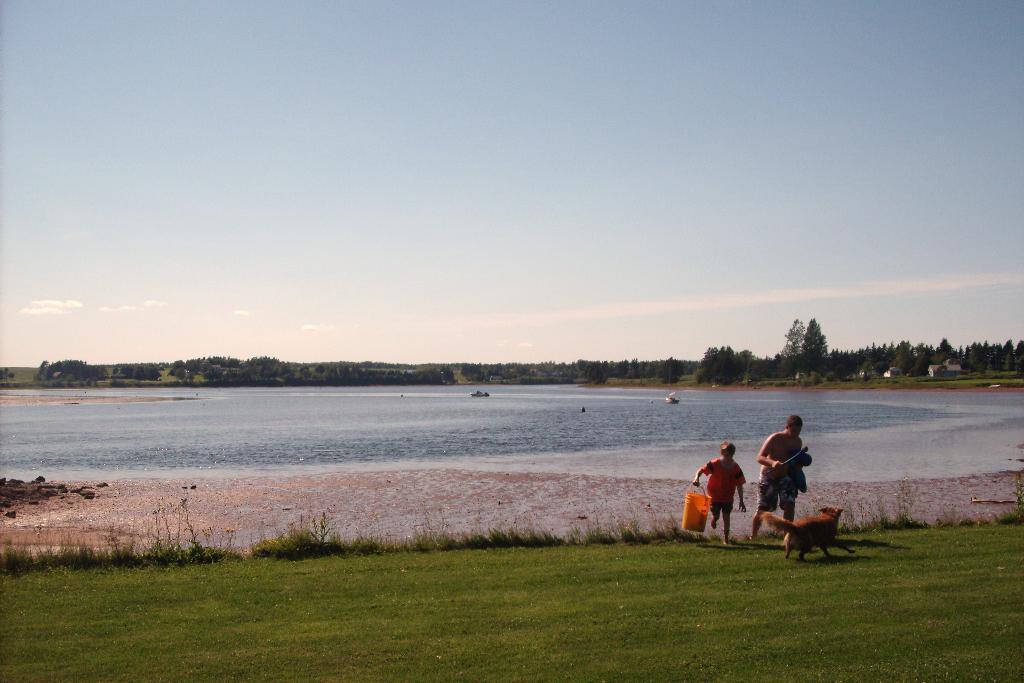In one or two sentences, can you explain what this image depicts? In this picture I can see the grass in front and I can see 2 boys and a dog in the middle of this picture and I can see the boy on the left is holding a bucket. In the background I can see the water, number of trees and the sky. 